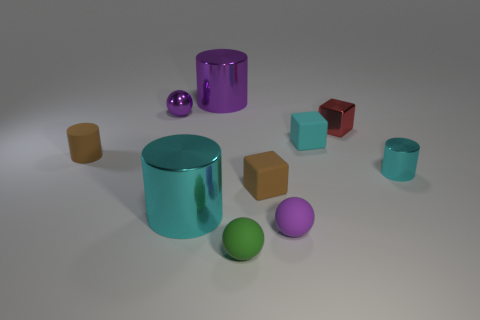Subtract all small metal cubes. How many cubes are left? 2 Subtract all red blocks. How many blocks are left? 2 Subtract all cylinders. How many objects are left? 6 Subtract 1 balls. How many balls are left? 2 Subtract all large purple cylinders. Subtract all big shiny objects. How many objects are left? 7 Add 1 small purple balls. How many small purple balls are left? 3 Add 2 brown cylinders. How many brown cylinders exist? 3 Subtract 0 gray spheres. How many objects are left? 10 Subtract all purple cubes. Subtract all purple cylinders. How many cubes are left? 3 Subtract all cyan cylinders. How many purple balls are left? 2 